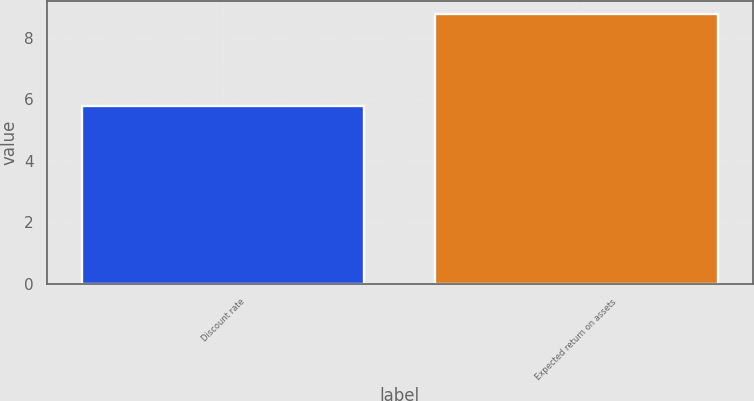Convert chart to OTSL. <chart><loc_0><loc_0><loc_500><loc_500><bar_chart><fcel>Discount rate<fcel>Expected return on assets<nl><fcel>5.77<fcel>8.75<nl></chart> 